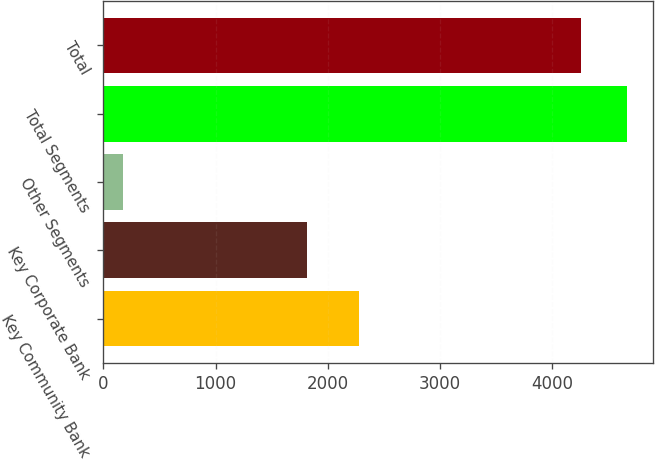Convert chart to OTSL. <chart><loc_0><loc_0><loc_500><loc_500><bar_chart><fcel>Key Community Bank<fcel>Key Corporate Bank<fcel>Other Segments<fcel>Total Segments<fcel>Total<nl><fcel>2275<fcel>1811<fcel>177<fcel>4664.6<fcel>4256<nl></chart> 